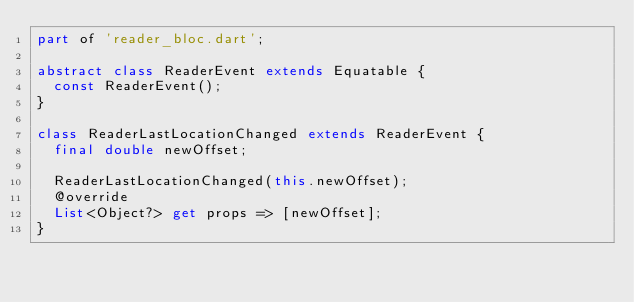Convert code to text. <code><loc_0><loc_0><loc_500><loc_500><_Dart_>part of 'reader_bloc.dart';

abstract class ReaderEvent extends Equatable {
  const ReaderEvent();
}

class ReaderLastLocationChanged extends ReaderEvent {
  final double newOffset;

  ReaderLastLocationChanged(this.newOffset);
  @override
  List<Object?> get props => [newOffset];
}
</code> 